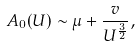<formula> <loc_0><loc_0><loc_500><loc_500>A _ { 0 } ( U ) \sim \mu + \frac { v } { U ^ { \frac { 3 } { 2 } } } ,</formula> 